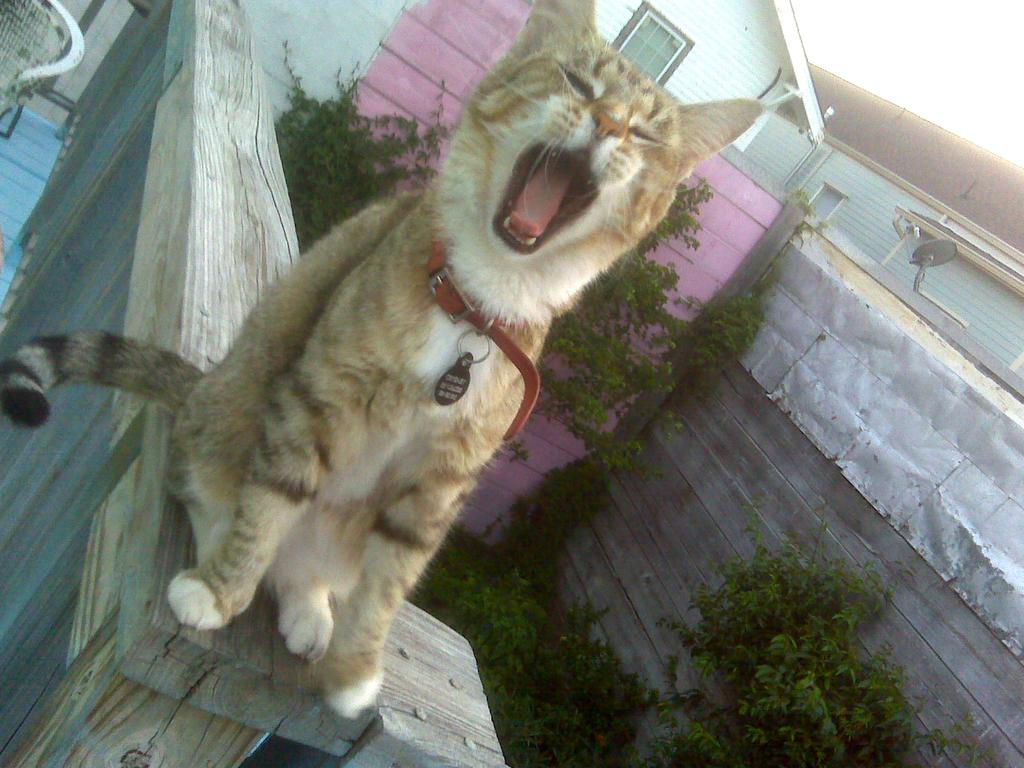What animal can be seen in the image? There is a cat in the image. What is the cat sitting on? The cat is sitting on a wooden object. What type of furniture is in the left corner of the image? There is a chair in the left corner of the image. What can be seen in the right corner of the image? There are trees and buildings in the right corner of the image. What type of watch is the cat wearing in the image? There is no watch visible on the cat in the image. 